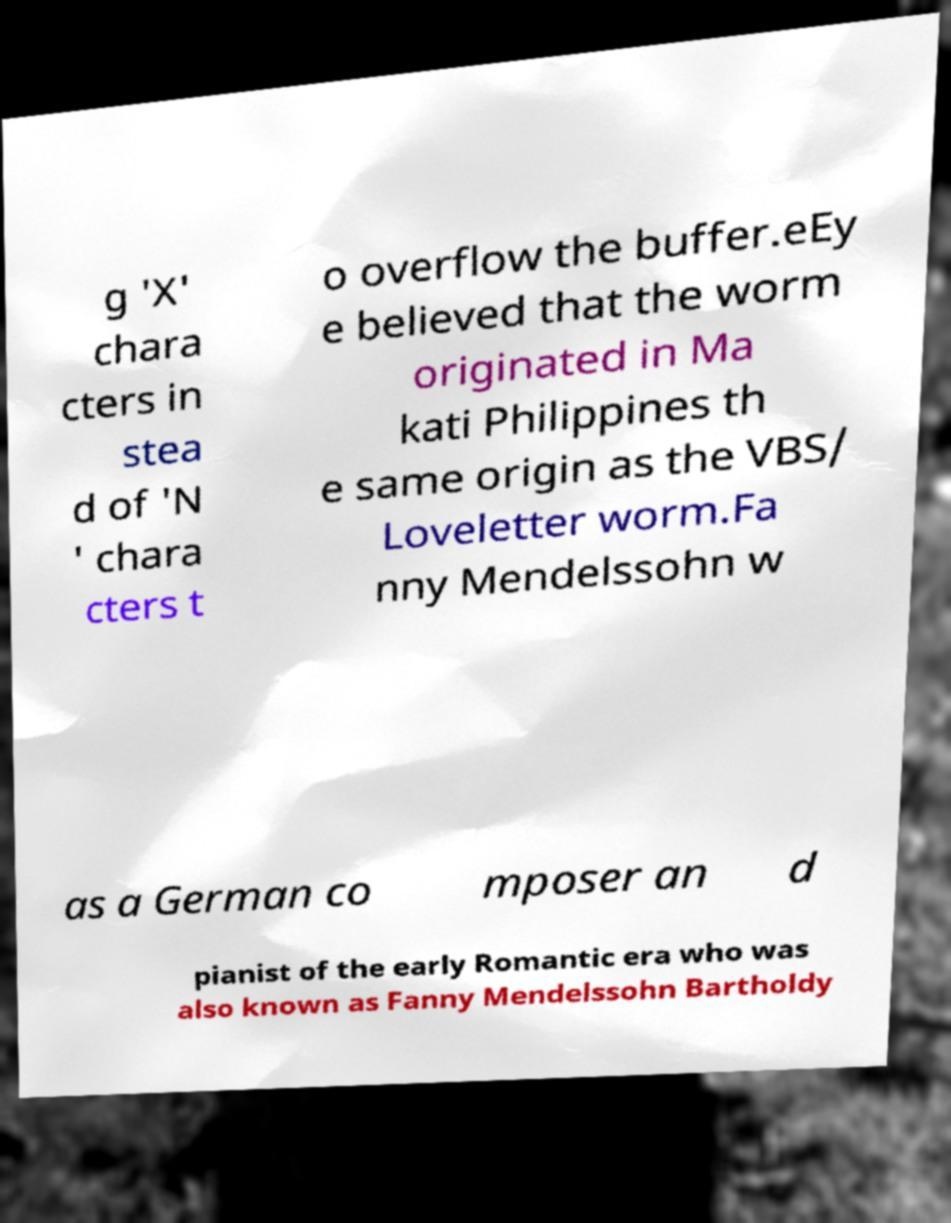There's text embedded in this image that I need extracted. Can you transcribe it verbatim? g 'X' chara cters in stea d of 'N ' chara cters t o overflow the buffer.eEy e believed that the worm originated in Ma kati Philippines th e same origin as the VBS/ Loveletter worm.Fa nny Mendelssohn w as a German co mposer an d pianist of the early Romantic era who was also known as Fanny Mendelssohn Bartholdy 